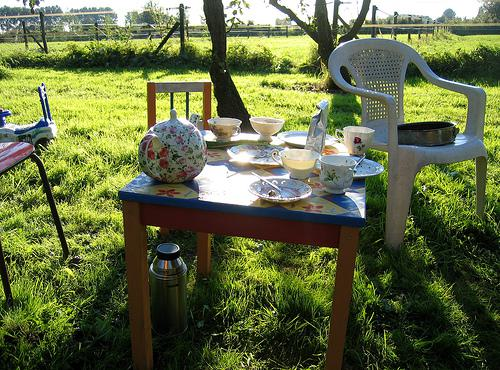What time of day does the scene seem to represent? The scene appears to depict late afternoon or early evening, given the long shadows and the soft, warm lighting which is typical of these times. 